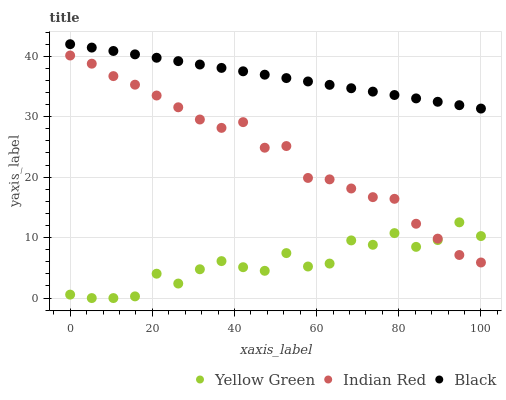Does Yellow Green have the minimum area under the curve?
Answer yes or no. Yes. Does Black have the maximum area under the curve?
Answer yes or no. Yes. Does Indian Red have the minimum area under the curve?
Answer yes or no. No. Does Indian Red have the maximum area under the curve?
Answer yes or no. No. Is Black the smoothest?
Answer yes or no. Yes. Is Yellow Green the roughest?
Answer yes or no. Yes. Is Indian Red the smoothest?
Answer yes or no. No. Is Indian Red the roughest?
Answer yes or no. No. Does Yellow Green have the lowest value?
Answer yes or no. Yes. Does Indian Red have the lowest value?
Answer yes or no. No. Does Black have the highest value?
Answer yes or no. Yes. Does Indian Red have the highest value?
Answer yes or no. No. Is Indian Red less than Black?
Answer yes or no. Yes. Is Black greater than Indian Red?
Answer yes or no. Yes. Does Indian Red intersect Yellow Green?
Answer yes or no. Yes. Is Indian Red less than Yellow Green?
Answer yes or no. No. Is Indian Red greater than Yellow Green?
Answer yes or no. No. Does Indian Red intersect Black?
Answer yes or no. No. 